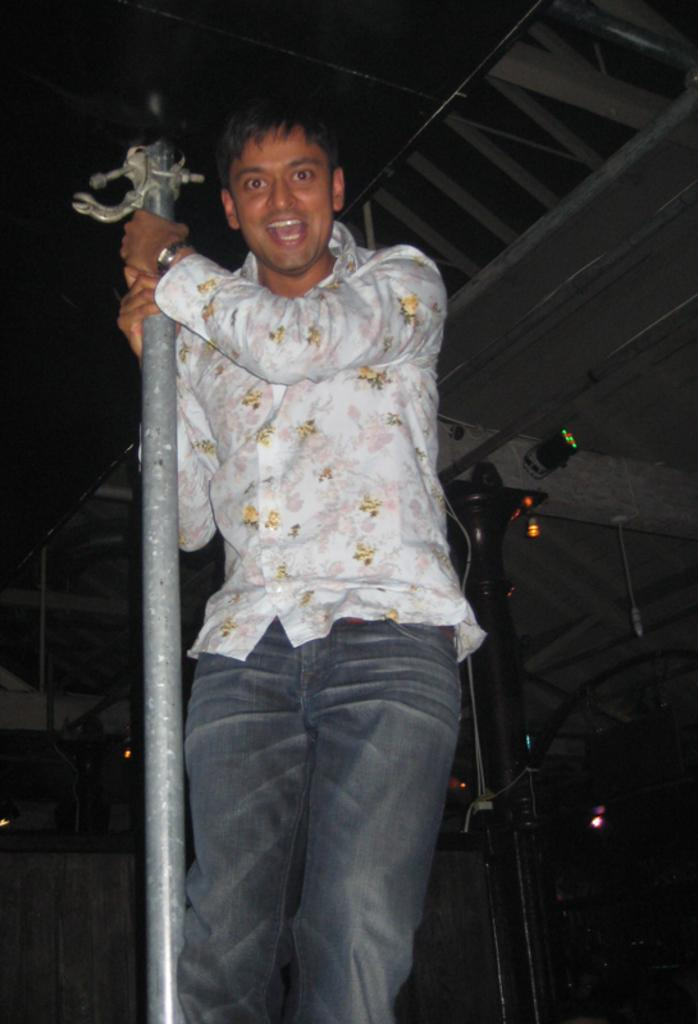What is the main subject of the image? There is a person in the image. What is the person wearing? The person is wearing clothes. What is the person holding in the image? The person is holding a pole with his hands. Are there any other poles visible in the image? Yes, there is another pole in the bottom right of the image. What type of jam is being spread on the turkey in the image? There is no jam or turkey present in the image; it features a person holding a pole and another pole in the bottom right. 